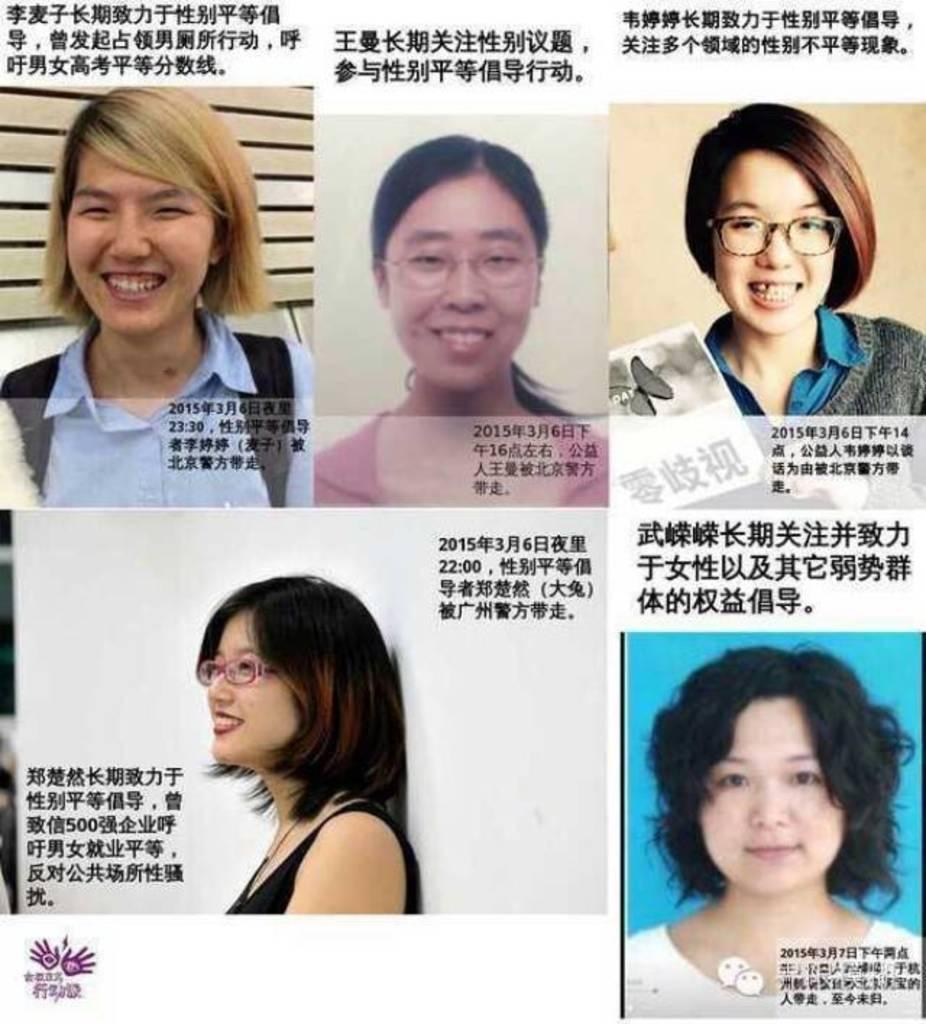Can you describe this image briefly? In this image, on the right side bottom, we can see a picture of a woman, in that picture, we can see some text written on it. On the right side, we can see a picture of a woman, on that image, we can see some text written on it. On the left side bottom, we can see a picture of a woman, on that image, we can see some text written on it. On the left side top, we can see a picture of a woman and some text written on it. In the middle of the image, we can see a picture of a woman and some text written on the image. 